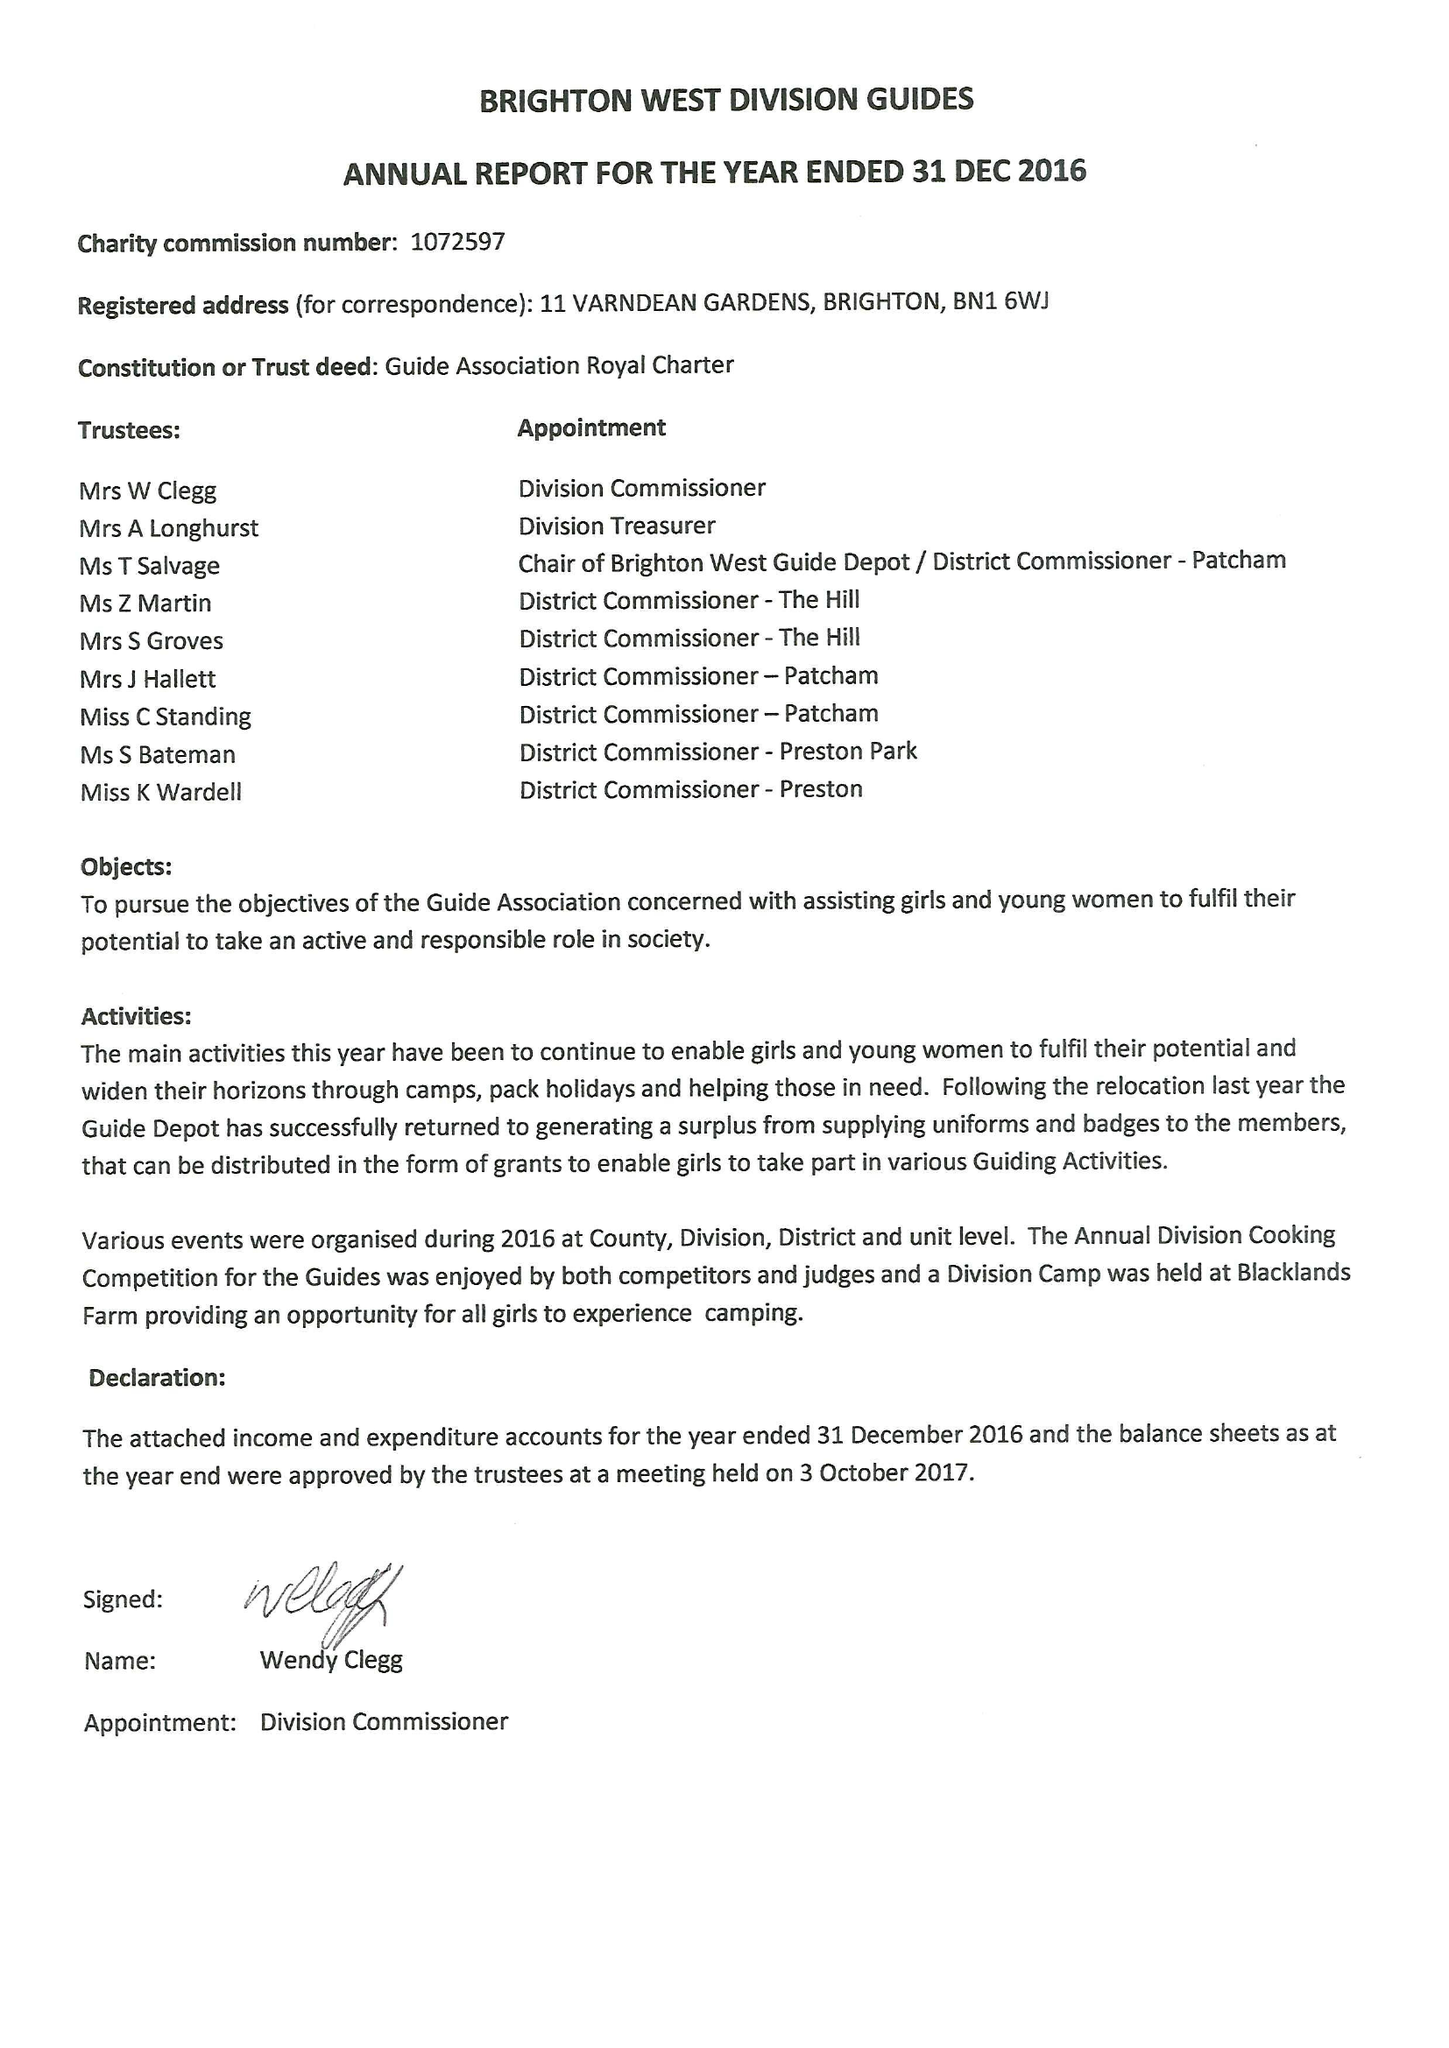What is the value for the charity_name?
Answer the question using a single word or phrase. Brighton West Division Guides 